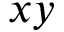<formula> <loc_0><loc_0><loc_500><loc_500>x y</formula> 